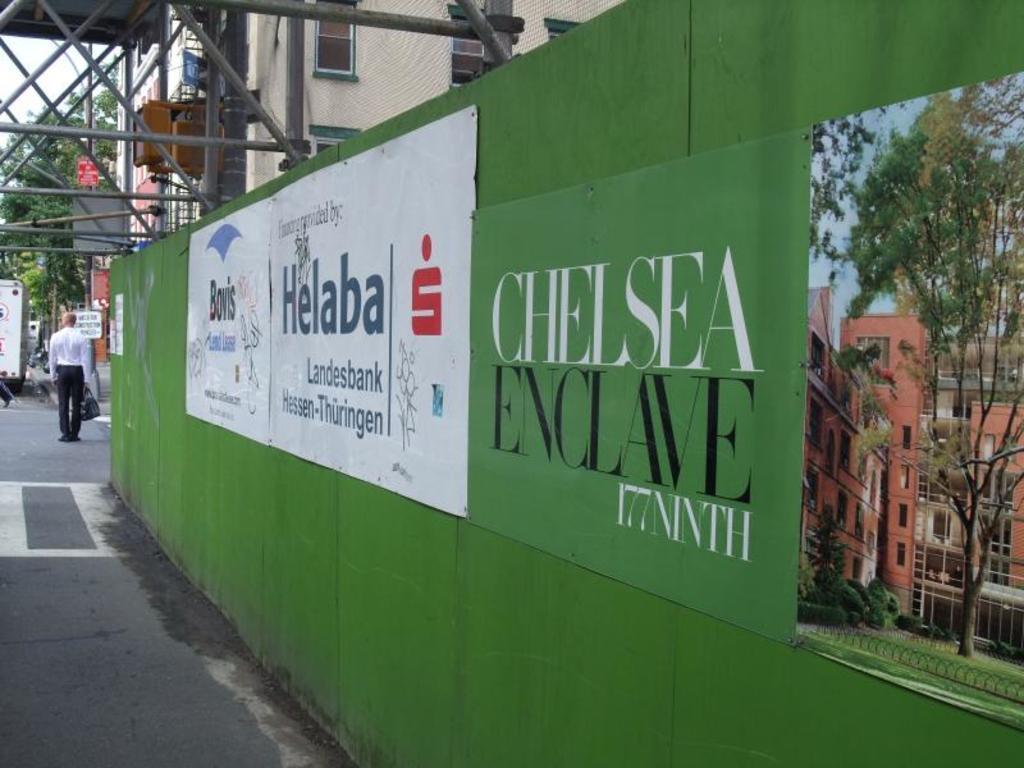Describe this image in one or two sentences. In this image we can see the green color wall on which we can see boards are fixed. Here we can see some edited text, buildings and trees in the picture. In the background, we can see a person walking on the road, buildings, poles, trees and the sky. 